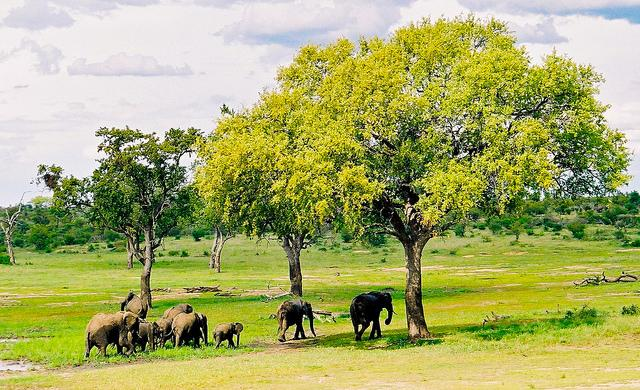How many elephants are there to lead this herd? Please explain your reasoning. two. They are up in the front of the others 